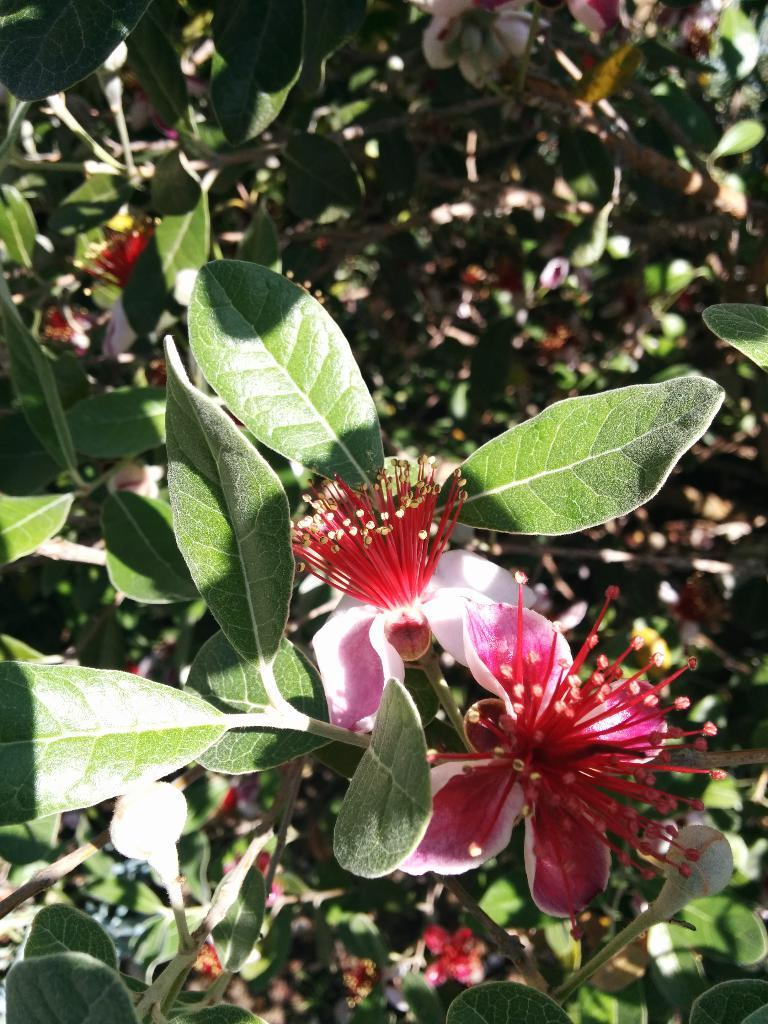What type of living organisms can be seen in the image? Flowers and plants can be seen in the image. Can you describe the plants in the image? The plants in the image are flowers. What type of earthquake can be seen in the image? There is no earthquake present in the image. What type of cracker is visible in the image? There is no cracker present in the image. 